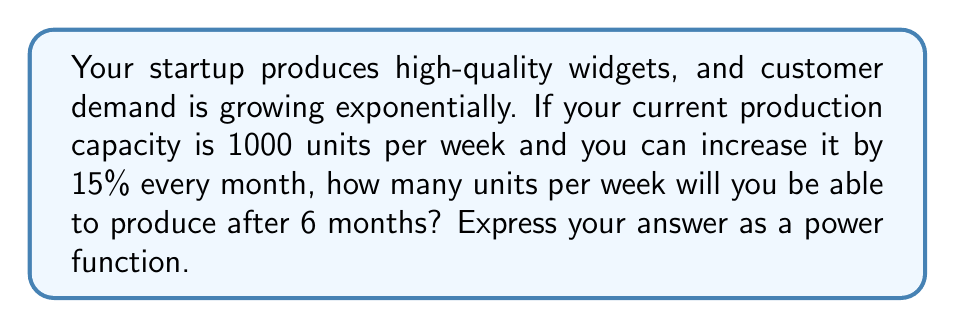Help me with this question. Let's approach this step-by-step:

1) First, we need to identify the base and exponent of our power function:
   - The base is the monthly growth rate: $1 + 15\% = 1.15$
   - The exponent is the number of months: 6

2) We can express the growth over 6 months as:
   $$(1.15)^6$$

3) Now, we need to multiply this by the initial production capacity:
   $$1000 \cdot (1.15)^6$$

4) This gives us our power function. Let's calculate the result:
   $$1000 \cdot (1.15)^6 = 1000 \cdot 2.3131 = 2313.1$$

5) Rounding to the nearest whole number (as we can't produce partial units), we get 2313 units per week.

This demonstrates how exponential growth can rapidly scale production capacity, allowing a quality-focused business to meet increasing customer demand efficiently.
Answer: $1000 \cdot (1.15)^6 \approx 2313$ units/week 